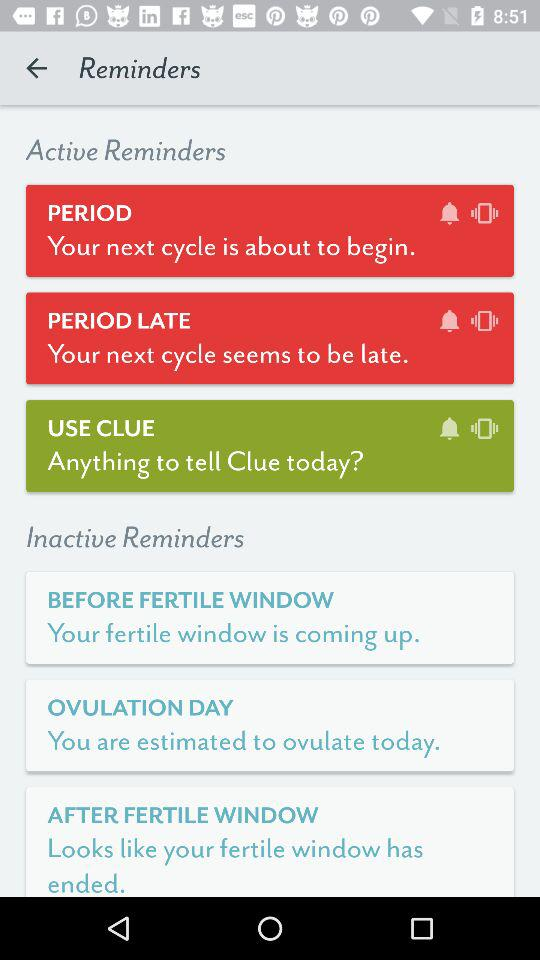What are the active reminders? The active reminders are "PERIOD", "PERIOD LATE" and "USE CLUE". 